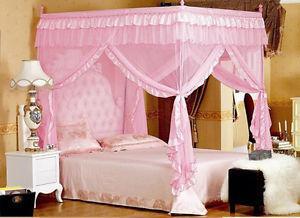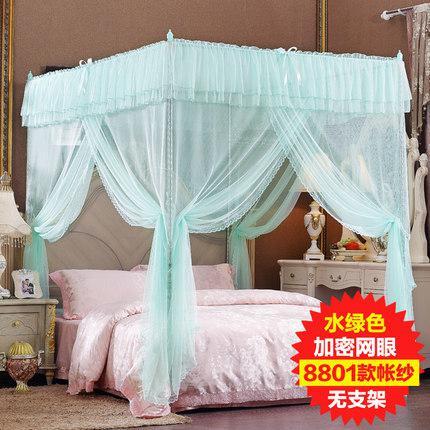The first image is the image on the left, the second image is the image on the right. For the images shown, is this caption "There is a nightstand next to a rounded mosquito net or canopy that covers the bed." true? Answer yes or no. No. The first image is the image on the left, the second image is the image on the right. Considering the images on both sides, is "None of the nets above the bed are pink or yellow." valid? Answer yes or no. No. 